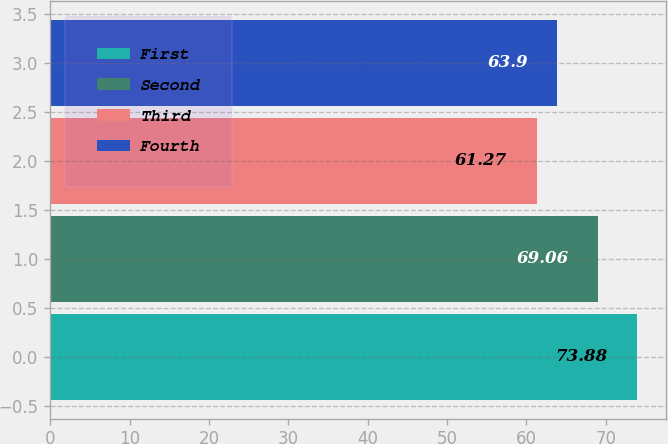Convert chart. <chart><loc_0><loc_0><loc_500><loc_500><bar_chart><fcel>First<fcel>Second<fcel>Third<fcel>Fourth<nl><fcel>73.88<fcel>69.06<fcel>61.27<fcel>63.9<nl></chart> 